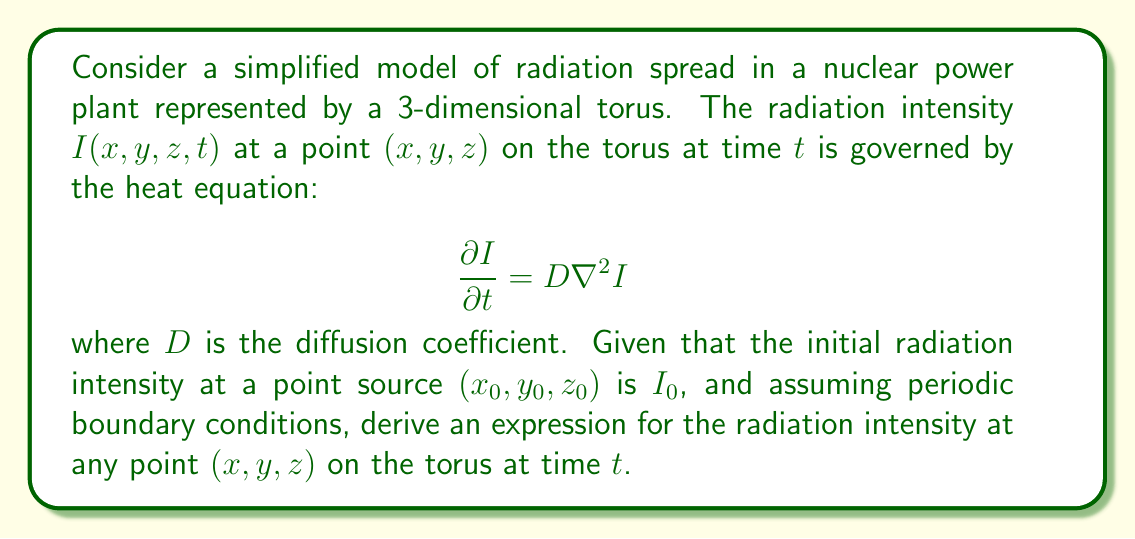Give your solution to this math problem. To solve this problem, we'll follow these steps:

1) The heat equation on a 3D torus with periodic boundary conditions can be solved using Fourier series.

2) The solution for a point source on a torus is given by:

   $$I(x,y,z,t) = \frac{I_0}{(4\pi Dt)^{3/2}} \sum_{n,m,k=-\infty}^{\infty} \exp\left(-\frac{[(x-x_0+nL_x)^2 + (y-y_0+mL_y)^2 + (z-z_0+kL_z)^2]}{4Dt}\right)$$

   where $L_x$, $L_y$, and $L_z$ are the dimensions of the torus.

3) This solution represents the superposition of infinite image sources due to the periodic boundary conditions.

4) The summation over $n$, $m$, and $k$ accounts for all these image sources.

5) As $t$ increases, the radiation spreads out, and the intensity at any given point decreases.

6) The exponential term represents the Gaussian distribution of the radiation intensity.

7) The prefactor $\frac{I_0}{(4\pi Dt)^{3/2}}$ ensures that the total radiation (integral over all space) remains constant and equal to $I_0$.

This solution allows policy analysts to model how radiation would spread in a nuclear power plant over time, which is crucial for safety assessments and emergency planning.
Answer: $$I(x,y,z,t) = \frac{I_0}{(4\pi Dt)^{3/2}} \sum_{n,m,k=-\infty}^{\infty} \exp\left(-\frac{[(x-x_0+nL_x)^2 + (y-y_0+mL_y)^2 + (z-z_0+kL_z)^2]}{4Dt}\right)$$ 